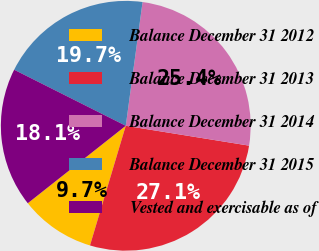<chart> <loc_0><loc_0><loc_500><loc_500><pie_chart><fcel>Balance December 31 2012<fcel>Balance December 31 2013<fcel>Balance December 31 2014<fcel>Balance December 31 2015<fcel>Vested and exercisable as of<nl><fcel>9.73%<fcel>27.08%<fcel>25.39%<fcel>19.74%<fcel>18.05%<nl></chart> 